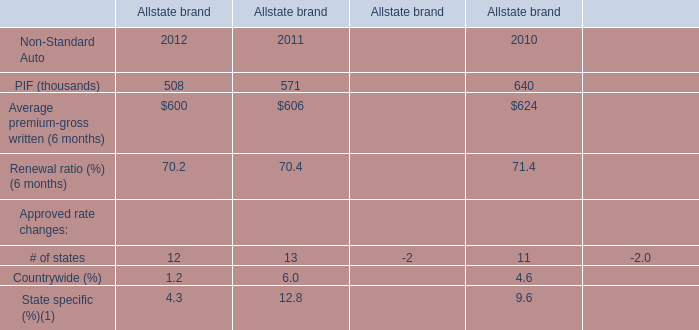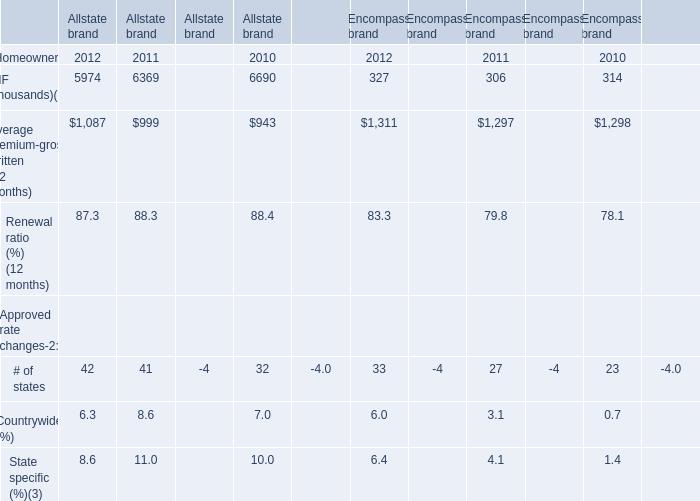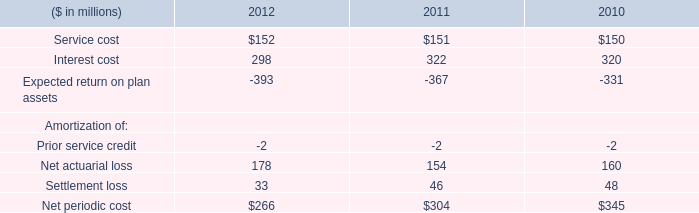What's the average of Average premium-gross written of Allstate brand in 2012 and 2011? (in thousand) 
Computations: ((1087 + 999) / 2)
Answer: 1043.0. 